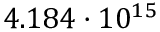Convert formula to latex. <formula><loc_0><loc_0><loc_500><loc_500>4 . 1 8 4 \cdot 1 0 ^ { 1 5 }</formula> 